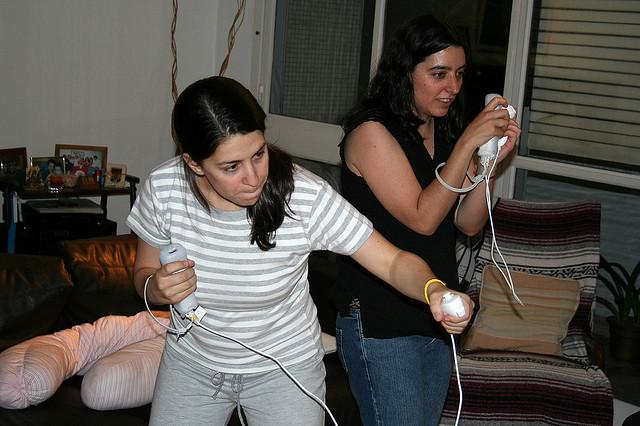What is probably in front of them?

Choices:
A) video game
B) radio
C) laptop
D) computer video game 